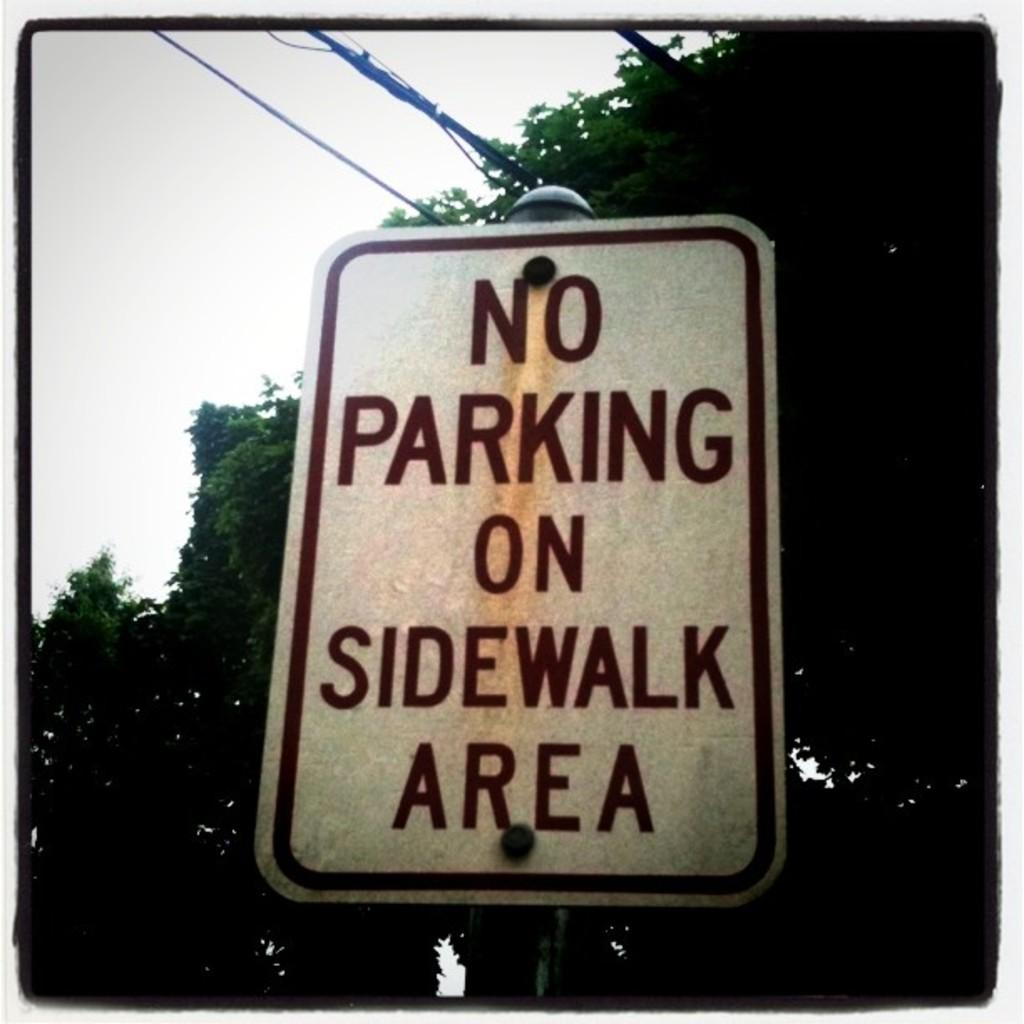<image>
Present a compact description of the photo's key features. A sign stating there is no parking on the sidewalk area 